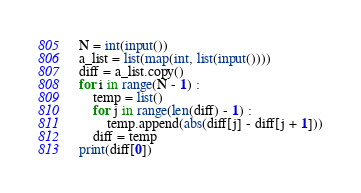<code> <loc_0><loc_0><loc_500><loc_500><_Python_>N = int(input())
a_list = list(map(int, list(input())))
diff = a_list.copy()
for i in range(N - 1) :
    temp = list()
    for j in range(len(diff) - 1) :
        temp.append(abs(diff[j] - diff[j + 1]))
    diff = temp
print(diff[0])</code> 